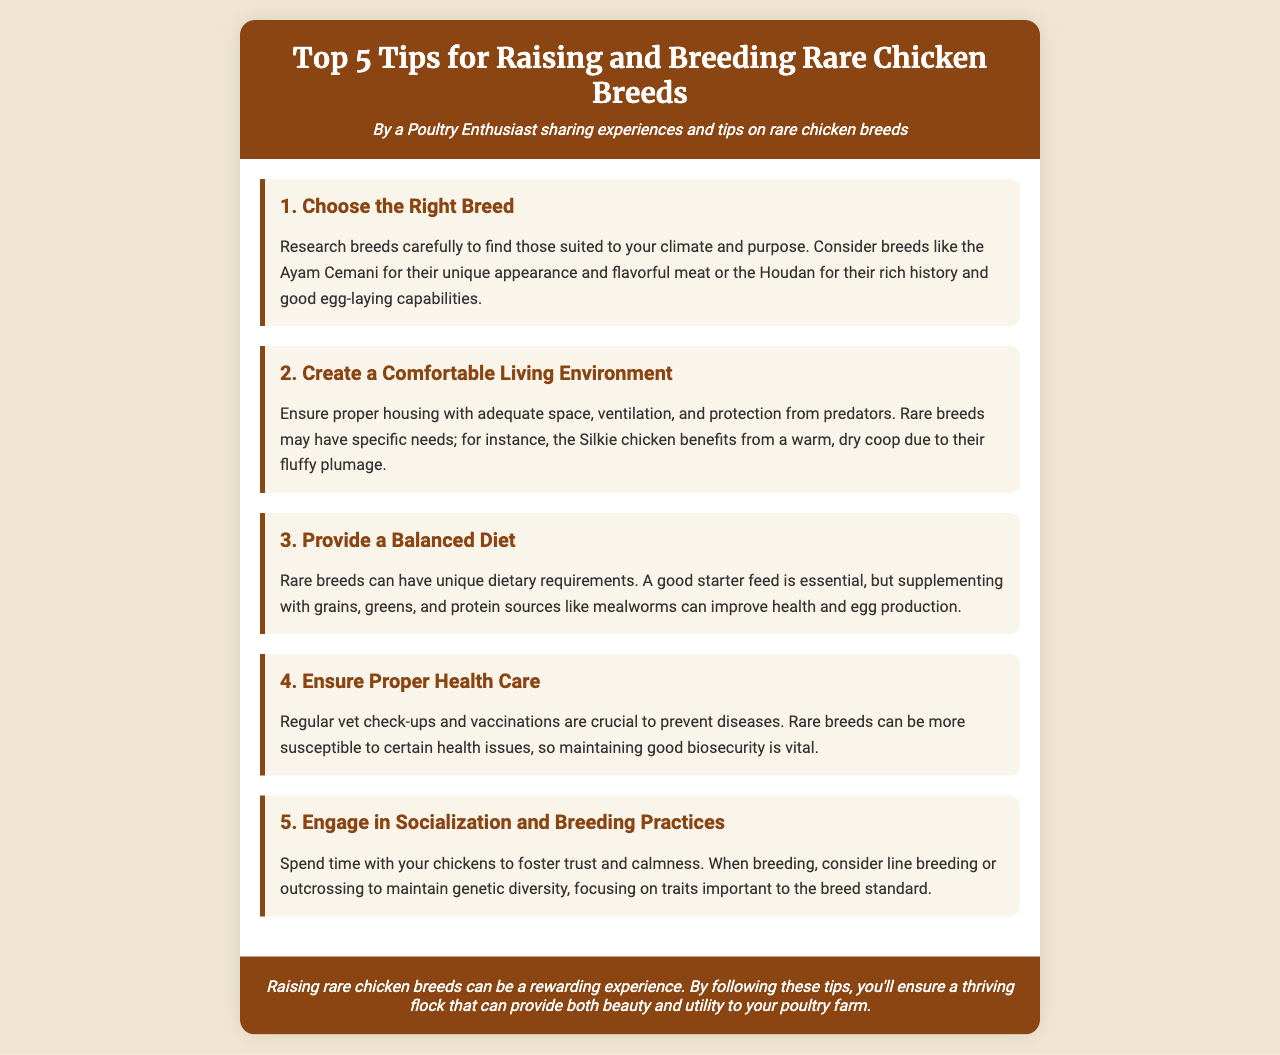What is the title of the brochure? The title of the brochure is displayed prominently at the top.
Answer: Top 5 Tips for Raising and Breeding Rare Chicken Breeds Who is the author of the brochure? The author of the brochure is mentioned below the title.
Answer: A Poultry Enthusiast Which breed is recommended for its unique appearance and flavorful meat? The specific breed is mentioned as an example of a suitable choice.
Answer: Ayam Cemani What is an essential part of a comfortable living environment for rare breeds? The living environment requirements are detailed in the brochure.
Answer: Adequate space What should be included in a balanced diet for rare chicken breeds? The document lists dietary supplements beneficial for health and egg production.
Answer: Grains, greens, and protein sources What is crucial to prevent diseases in rare breeds? The brochure emphasizes a specific practice for maintaining health in chickens.
Answer: Regular vet check-ups Which practice should be considered to maintain genetic diversity? The brochure suggests a breeding practice for ensuring diversity.
Answer: Outcrossing What color theme is used in the brochure's header? The color of the header indicates the design elements chosen for the document.
Answer: Brown 